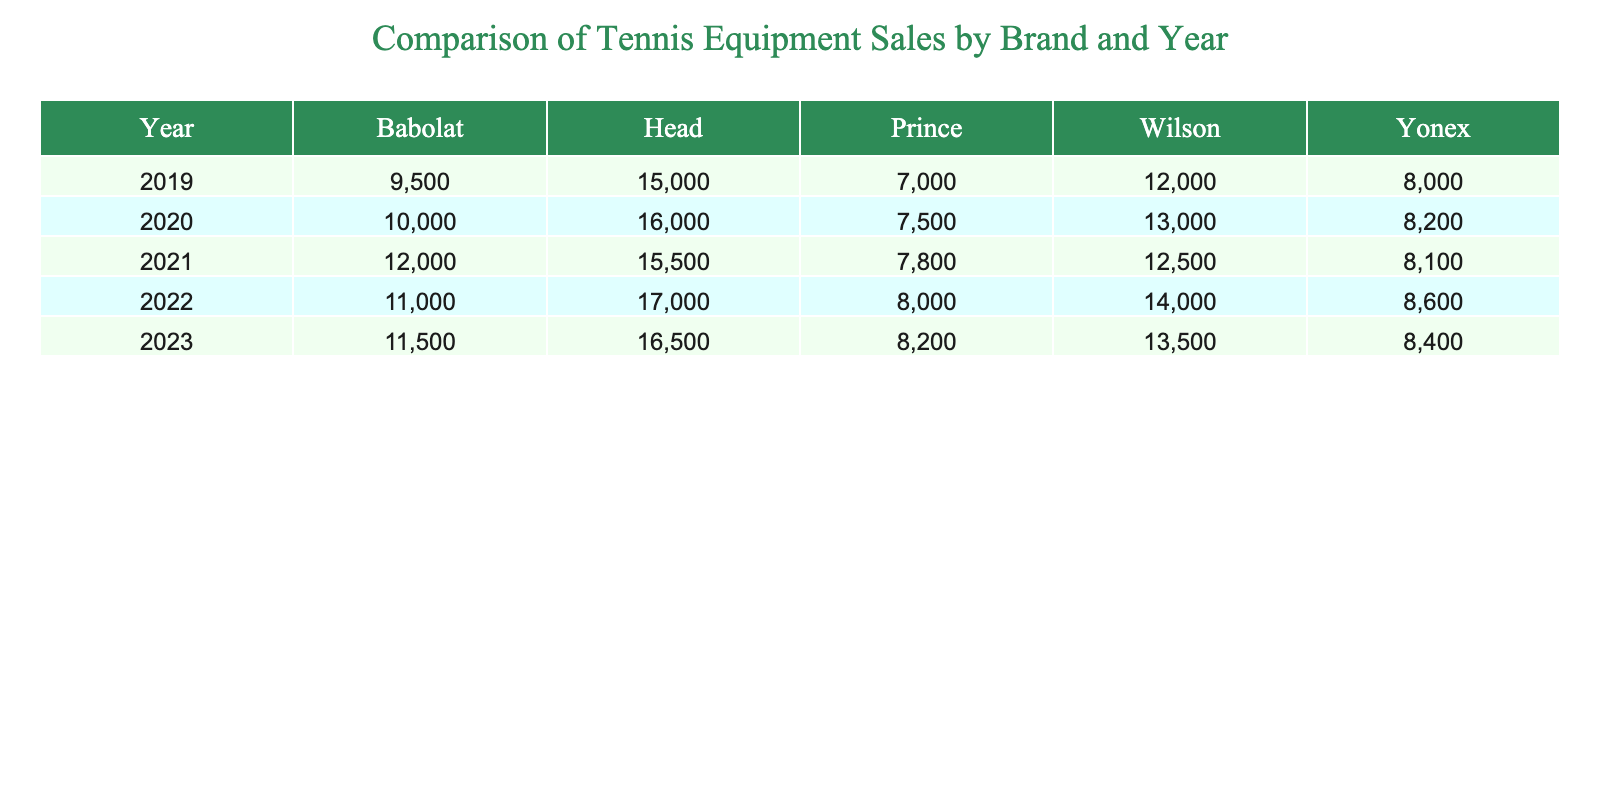What was the sales figure for Babolat in 2022? According to the table for the year 2022, the sales figure for Babolat is listed as 11,000.
Answer: 11000 Which brand had the highest sales in 2021? Looking at the data for 2021, the sales figures show that Head had the highest sales at 15,500 compared to other brands.
Answer: Head What is the average sales figure for Wilson across all years? To calculate the average sales for Wilson, sum the sales for each year: (12,000 + 13,000 + 12,500 + 14,000 + 13,500) = 65,000. Then divide by 5 (the number of years): 65,000 / 5 = 13,000.
Answer: 13000 Did Prince's sales increase every year from 2019 to 2023? By examining Prince's sales from 2019 (7,000) to 2023 (8,200), there are increases for most years, but there were fluctuations (2019 to 2020 saw an increase, but the increase from 2020 to 2021 is less, and 2021 to 2022 is a similar increase). So, the sales did not consistently increase each year.
Answer: No What is the total sales figure for Yonex from 2019 to 2023? To find the total sales for Yonex, sum the sales figures for each year: 8,000 (2019) + 8,200 (2020) + 8,100 (2021) + 8,600 (2022) + 8,400 (2023) = 41,300.
Answer: 41300 Which brand had the least sales in 2020? In the year 2020, the sales figures indicate that Babolat had the least sales with a total of 10,000, when compared to the sales figures of the other brands.
Answer: Babolat How much did the total sales for Wilson increase from 2019 to 2023? To calculate the increase for Wilson, subtract the 2019 sales of 12,000 from the 2023 sales of 13,500, resulting in an increase of 1,500 over the four-year span.
Answer: 1500 What is the difference in sales between the highest and lowest brands in 2021? The highest sales in 2021 were for Head at 15,500, while the lowest was for Babolat at 12,000. The difference is calculated as 15,500 - 12,000 = 3,500.
Answer: 3500 Was the sales figure for Head in 2022 greater than the sales for Yonex in the same year? In 2022, Head's sales were 17,000, while Yonex had sales of 8,600. Since 17,000 is greater than 8,600, the statement is true.
Answer: Yes 